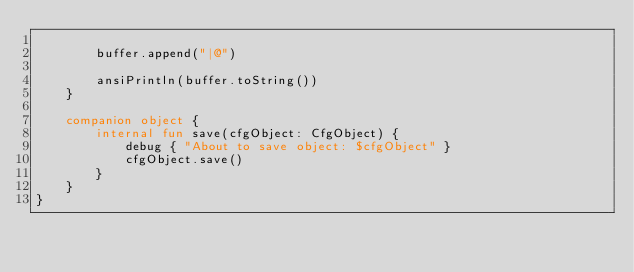<code> <loc_0><loc_0><loc_500><loc_500><_Kotlin_>
        buffer.append("|@")

        ansiPrintln(buffer.toString())
    }

    companion object {
        internal fun save(cfgObject: CfgObject) {
            debug { "About to save object: $cfgObject" }
            cfgObject.save()
        }
    }
}
</code> 